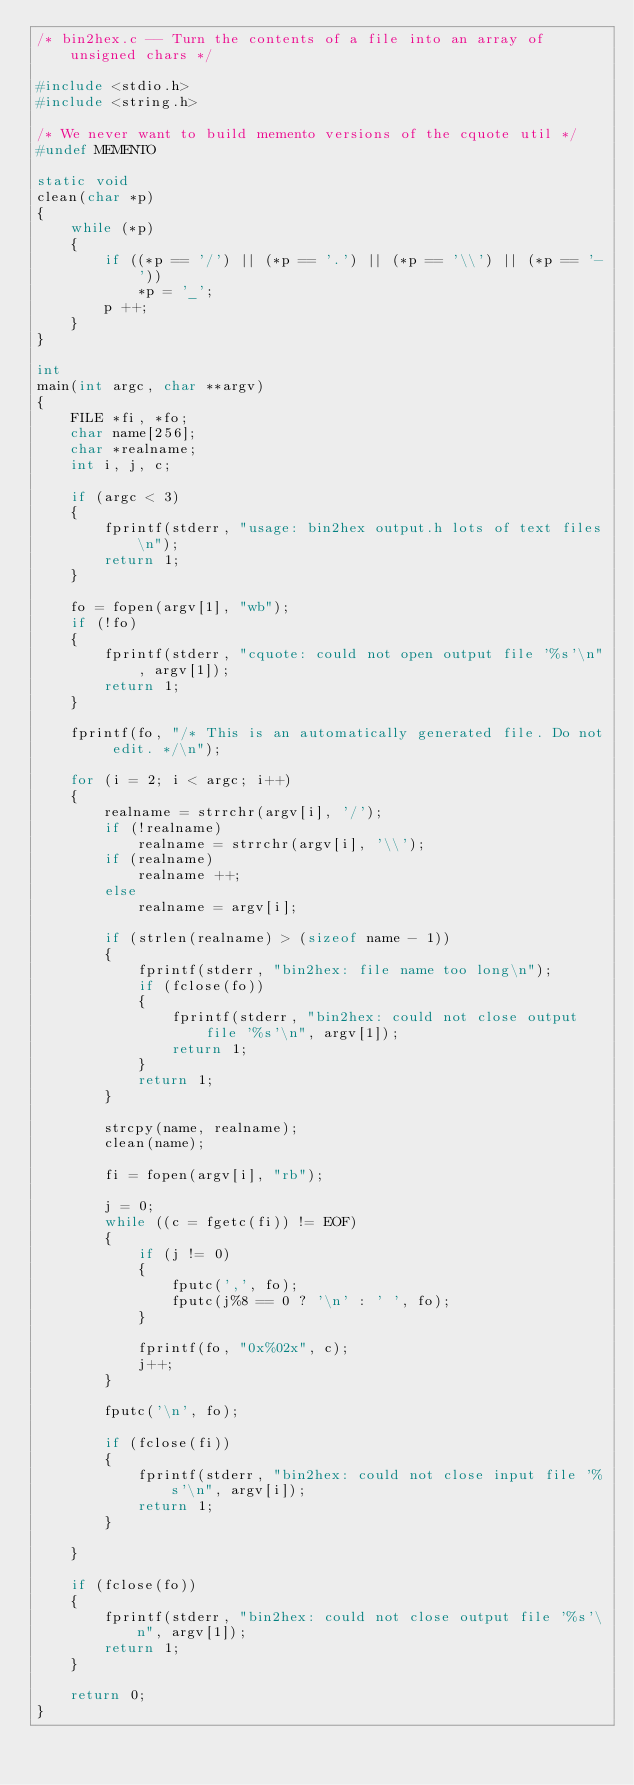<code> <loc_0><loc_0><loc_500><loc_500><_C_>/* bin2hex.c -- Turn the contents of a file into an array of unsigned chars */

#include <stdio.h>
#include <string.h>

/* We never want to build memento versions of the cquote util */
#undef MEMENTO

static void
clean(char *p)
{
	while (*p)
	{
		if ((*p == '/') || (*p == '.') || (*p == '\\') || (*p == '-'))
			*p = '_';
		p ++;
	}
}

int
main(int argc, char **argv)
{
	FILE *fi, *fo;
	char name[256];
	char *realname;
	int i, j, c;

	if (argc < 3)
	{
		fprintf(stderr, "usage: bin2hex output.h lots of text files\n");
		return 1;
	}

	fo = fopen(argv[1], "wb");
	if (!fo)
	{
		fprintf(stderr, "cquote: could not open output file '%s'\n", argv[1]);
		return 1;
	}

	fprintf(fo, "/* This is an automatically generated file. Do not edit. */\n");

	for (i = 2; i < argc; i++)
	{
		realname = strrchr(argv[i], '/');
		if (!realname)
			realname = strrchr(argv[i], '\\');
		if (realname)
			realname ++;
		else
			realname = argv[i];

		if (strlen(realname) > (sizeof name - 1))
		{
			fprintf(stderr, "bin2hex: file name too long\n");
			if (fclose(fo))
			{
				fprintf(stderr, "bin2hex: could not close output file '%s'\n", argv[1]);
				return 1;
			}
			return 1;
		}

		strcpy(name, realname);
		clean(name);

		fi = fopen(argv[i], "rb");

		j = 0;
		while ((c = fgetc(fi)) != EOF)
		{
			if (j != 0)
			{
				fputc(',', fo);
				fputc(j%8 == 0 ? '\n' : ' ', fo);
			}

			fprintf(fo, "0x%02x", c);
			j++;
		}

		fputc('\n', fo);

		if (fclose(fi))
		{
			fprintf(stderr, "bin2hex: could not close input file '%s'\n", argv[i]);
			return 1;
		}

	}

	if (fclose(fo))
	{
		fprintf(stderr, "bin2hex: could not close output file '%s'\n", argv[1]);
		return 1;
	}

	return 0;
}
</code> 